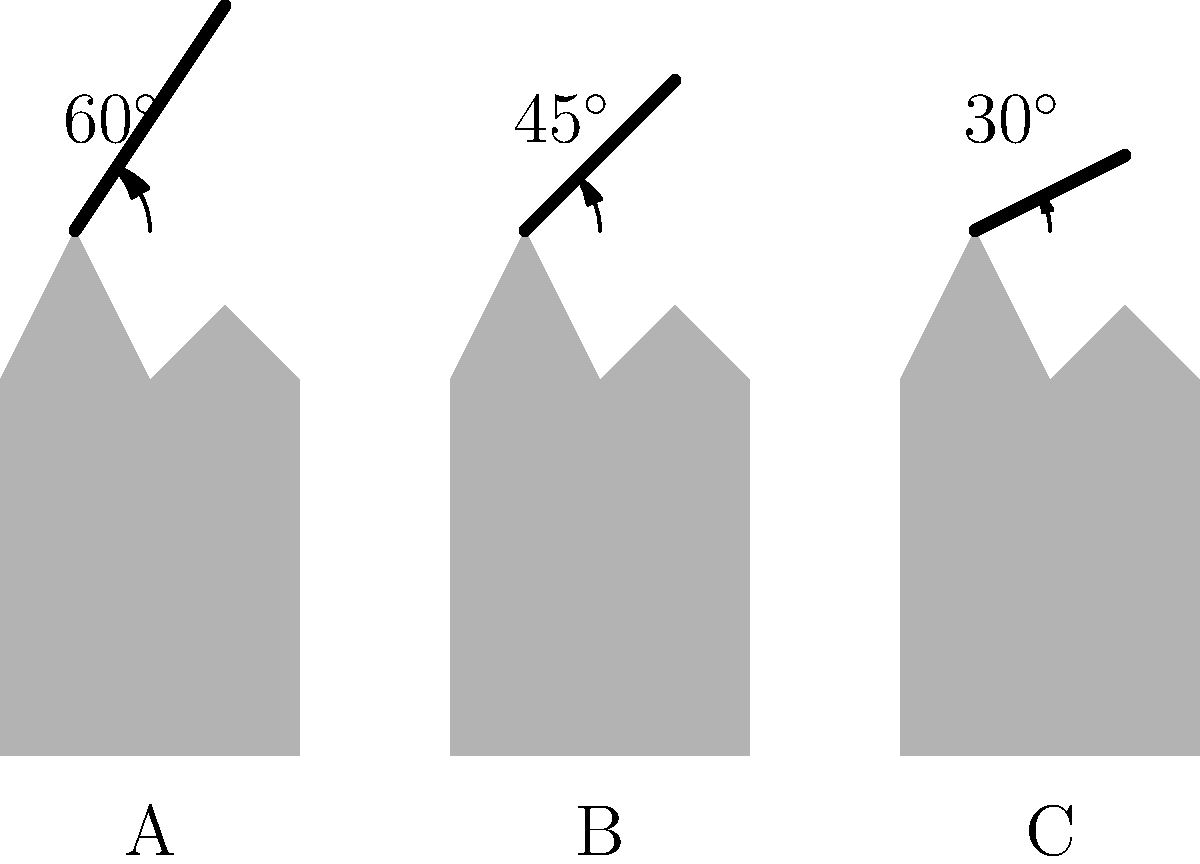In the context of classical theatrical sword-fighting scenes, analyze the biomechanical implications of the three sword-fighting stances (A, B, and C) illustrated above. Which stance would likely provide the best combination of stability and striking power, and why? To analyze the biomechanics of these sword-fighting stances, we need to consider several factors:

1. Angle of the sword:
   A: $60^\circ$
   B: $45^\circ$
   C: $30^\circ$

2. Body posture:
   All stances show a slightly bent knee position, which is good for stability and quick movement.

3. Stability:
   - A wider stance generally provides more stability.
   - Stance A appears to have the widest base of support.

4. Striking power:
   - Power in a strike comes from the rotation of the body and the leverage of the arm.
   - A higher sword angle allows for more potential energy to be converted into kinetic energy during a downward strike.

5. Range of motion:
   - A higher sword angle provides a greater range of motion for various types of strikes.

6. Energy efficiency:
   - Holding the sword at a higher angle requires more energy and can lead to faster fatigue.

Analyzing each stance:

A ($60^\circ$):
   + Highest striking power potential
   + Greatest range of motion
   + Good stability
   - Requires more energy to maintain

B ($45^\circ$):
   + Balanced between striking power and energy efficiency
   + Good range of motion
   + Decent stability

C ($30^\circ$):
   + Most energy-efficient to maintain
   + Quickest to initiate a strike
   - Limited striking power
   - Reduced range of motion

Considering these factors, stance B ($45^\circ$) likely provides the best combination of stability and striking power. It offers a good balance between the energy efficiency of a lower angle and the power potential of a higher angle. The $45^\circ$ angle allows for a variety of strikes while maintaining a strong, stable posture that can be held for extended periods without excessive fatigue.
Answer: Stance B ($45^\circ$) 